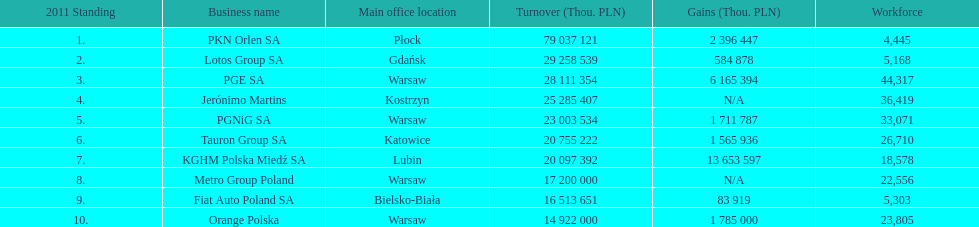What company is the only one with a revenue greater than 75,000,000 thou. pln? PKN Orlen SA. 